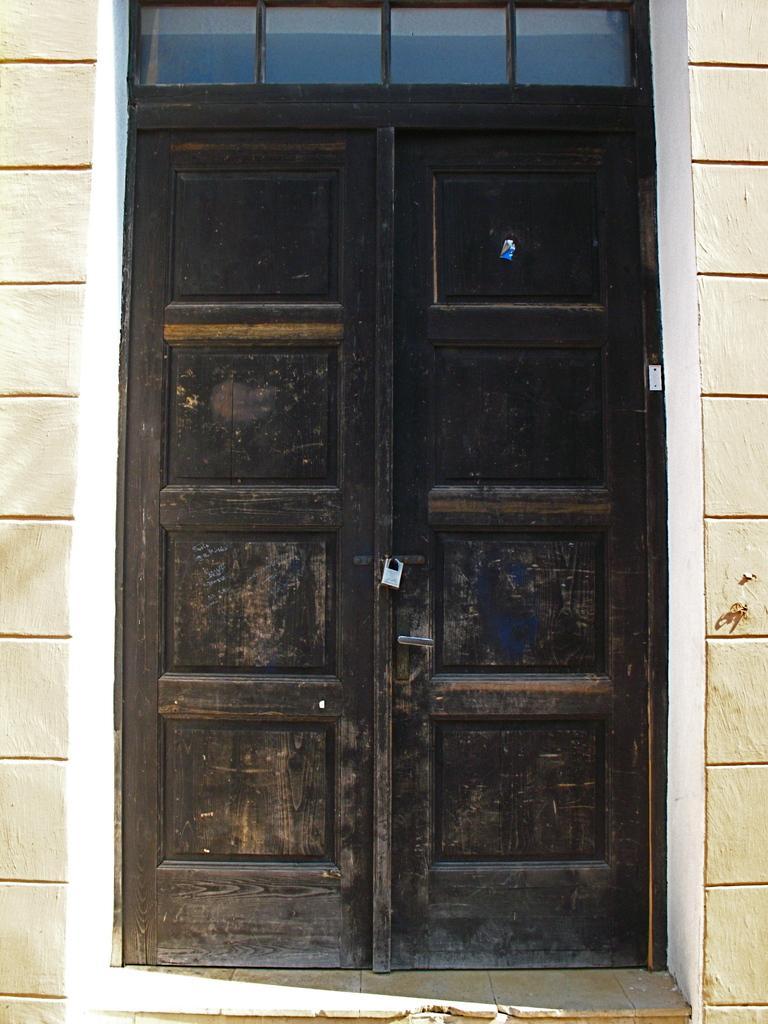Please provide a concise description of this image. In this image, we can see doors locked and in the background, there is a wall. 